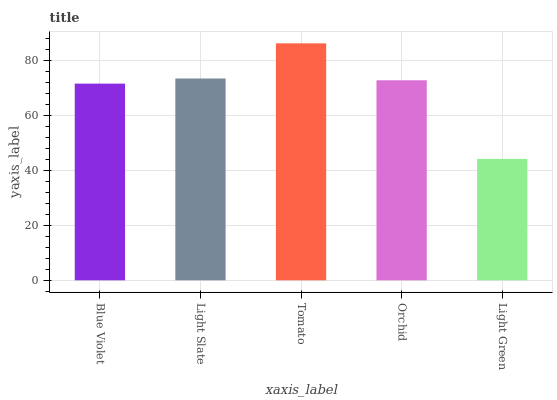Is Light Green the minimum?
Answer yes or no. Yes. Is Tomato the maximum?
Answer yes or no. Yes. Is Light Slate the minimum?
Answer yes or no. No. Is Light Slate the maximum?
Answer yes or no. No. Is Light Slate greater than Blue Violet?
Answer yes or no. Yes. Is Blue Violet less than Light Slate?
Answer yes or no. Yes. Is Blue Violet greater than Light Slate?
Answer yes or no. No. Is Light Slate less than Blue Violet?
Answer yes or no. No. Is Orchid the high median?
Answer yes or no. Yes. Is Orchid the low median?
Answer yes or no. Yes. Is Tomato the high median?
Answer yes or no. No. Is Light Green the low median?
Answer yes or no. No. 